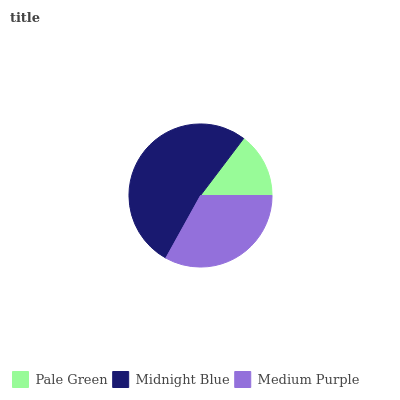Is Pale Green the minimum?
Answer yes or no. Yes. Is Midnight Blue the maximum?
Answer yes or no. Yes. Is Medium Purple the minimum?
Answer yes or no. No. Is Medium Purple the maximum?
Answer yes or no. No. Is Midnight Blue greater than Medium Purple?
Answer yes or no. Yes. Is Medium Purple less than Midnight Blue?
Answer yes or no. Yes. Is Medium Purple greater than Midnight Blue?
Answer yes or no. No. Is Midnight Blue less than Medium Purple?
Answer yes or no. No. Is Medium Purple the high median?
Answer yes or no. Yes. Is Medium Purple the low median?
Answer yes or no. Yes. Is Midnight Blue the high median?
Answer yes or no. No. Is Midnight Blue the low median?
Answer yes or no. No. 